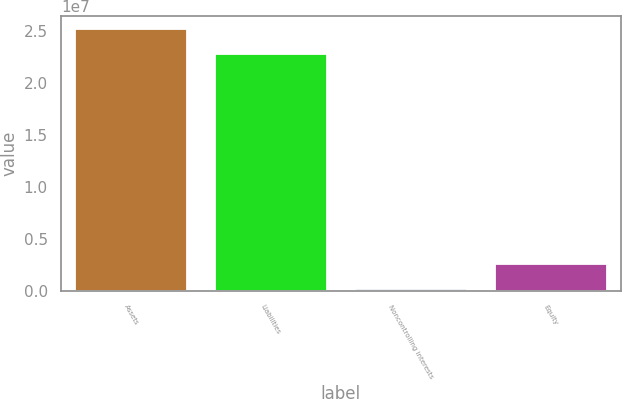<chart> <loc_0><loc_0><loc_500><loc_500><bar_chart><fcel>Assets<fcel>Liabilities<fcel>Noncontrolling interests<fcel>Equity<nl><fcel>2.52062e+07<fcel>2.2739e+07<fcel>140000<fcel>2.6072e+06<nl></chart> 